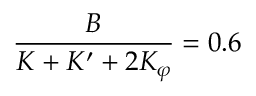<formula> <loc_0><loc_0><loc_500><loc_500>\frac { B } { K + K ^ { \prime } + 2 K _ { \varphi } } = 0 . 6</formula> 